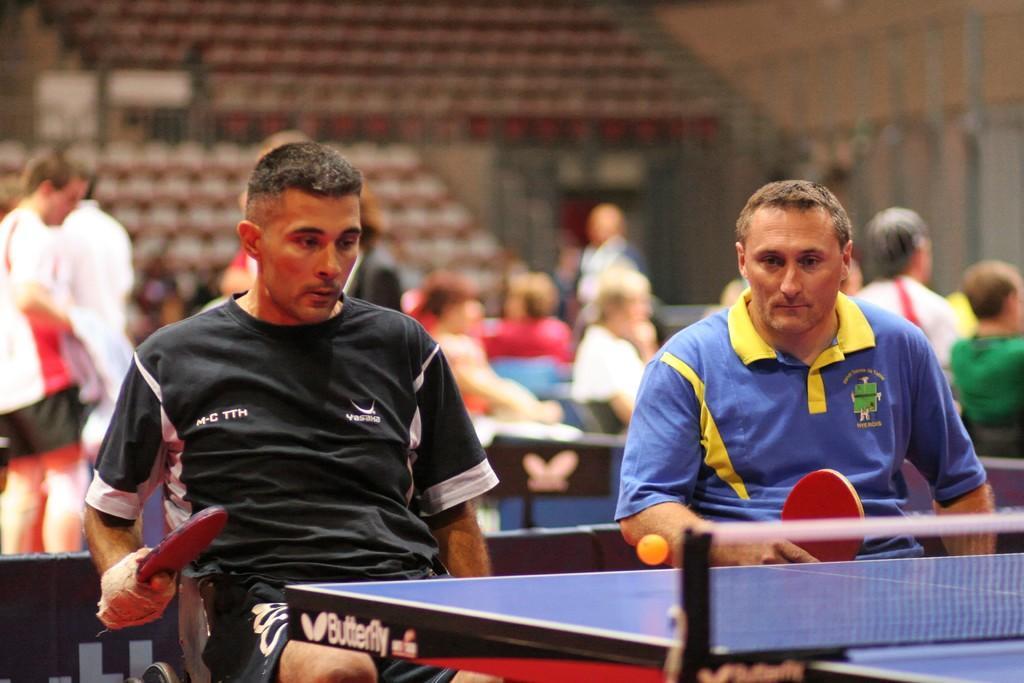How would you summarize this image in a sentence or two? In this image two persons are sitting on the chair in front of them there is there table tennis board and their playing with the bad back side we can see so many people are sitting on the chair and talking with each other some people of walking 